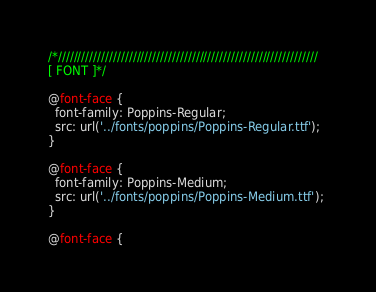Convert code to text. <code><loc_0><loc_0><loc_500><loc_500><_CSS_>



/*//////////////////////////////////////////////////////////////////
[ FONT ]*/

@font-face {
  font-family: Poppins-Regular;
  src: url('../fonts/poppins/Poppins-Regular.ttf'); 
}

@font-face {
  font-family: Poppins-Medium;
  src: url('../fonts/poppins/Poppins-Medium.ttf'); 
}

@font-face {</code> 